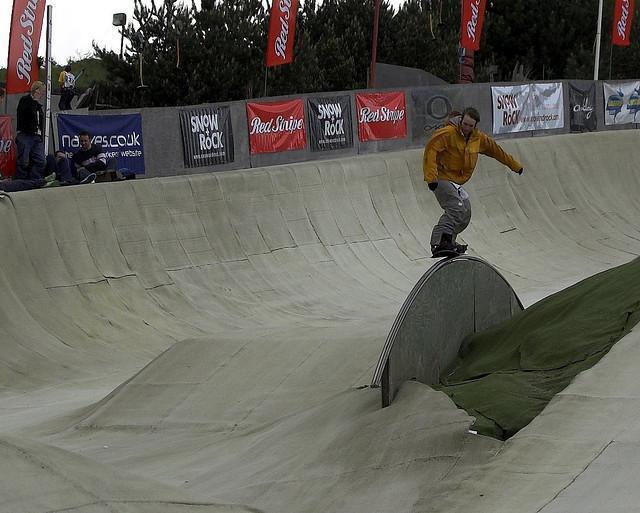How many people are in the photo?
Give a very brief answer. 4. How many people are there?
Give a very brief answer. 2. How many horses do not have riders?
Give a very brief answer. 0. 